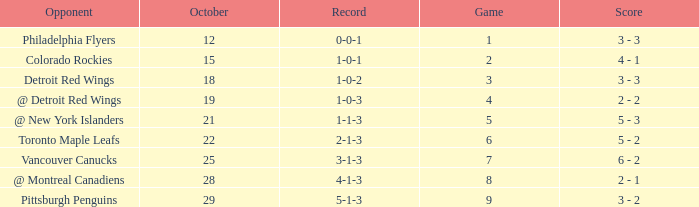Name the most october for game less than 1 None. 